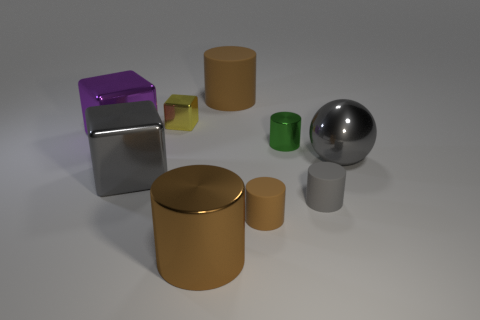Subtract all small yellow metallic blocks. How many blocks are left? 2 Subtract all green cylinders. How many cylinders are left? 4 Subtract all balls. How many objects are left? 8 Subtract all red cubes. Subtract all green balls. How many cubes are left? 3 Subtract 1 gray cubes. How many objects are left? 8 Subtract 2 cubes. How many cubes are left? 1 Subtract all brown cubes. How many yellow cylinders are left? 0 Subtract all large gray things. Subtract all gray matte cylinders. How many objects are left? 6 Add 7 tiny green metal cylinders. How many tiny green metal cylinders are left? 8 Add 4 small red balls. How many small red balls exist? 4 